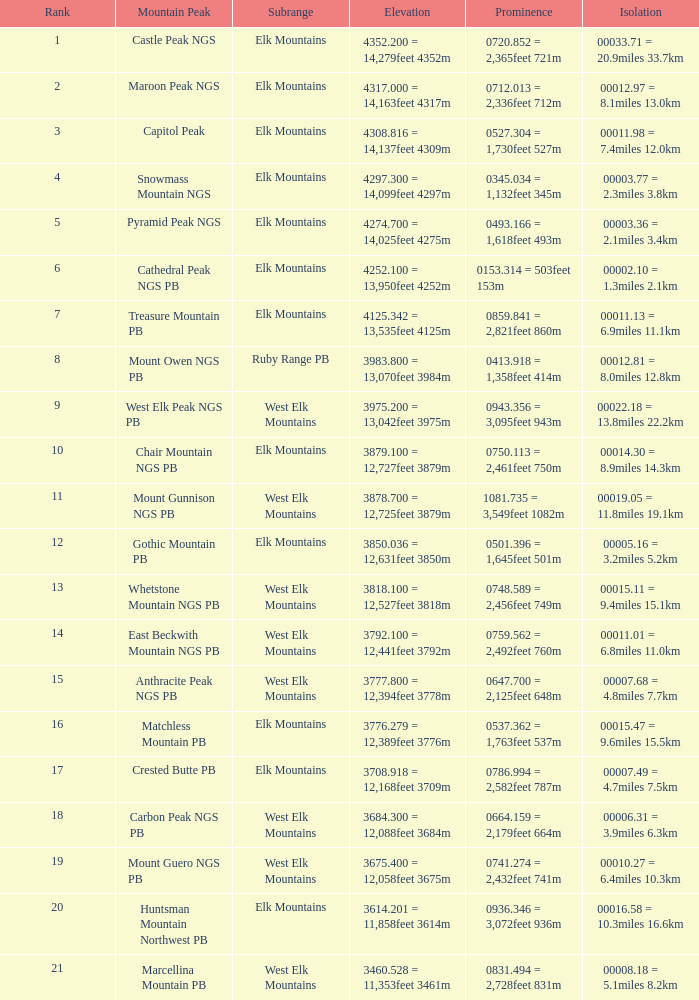Name the Rank of Rank Mountain Peak of crested butte pb? 17.0. 